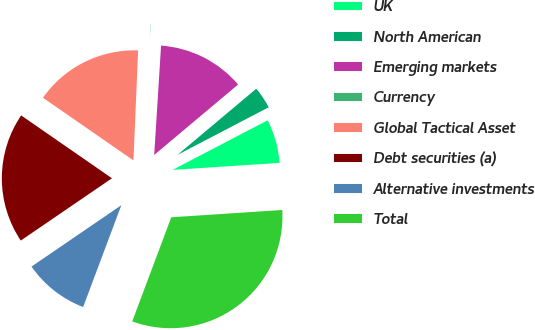<chart> <loc_0><loc_0><loc_500><loc_500><pie_chart><fcel>UK<fcel>North American<fcel>Emerging markets<fcel>Currency<fcel>Global Tactical Asset<fcel>Debt securities (a)<fcel>Alternative investments<fcel>Total<nl><fcel>6.61%<fcel>3.46%<fcel>12.89%<fcel>0.32%<fcel>16.04%<fcel>19.18%<fcel>9.75%<fcel>31.76%<nl></chart> 